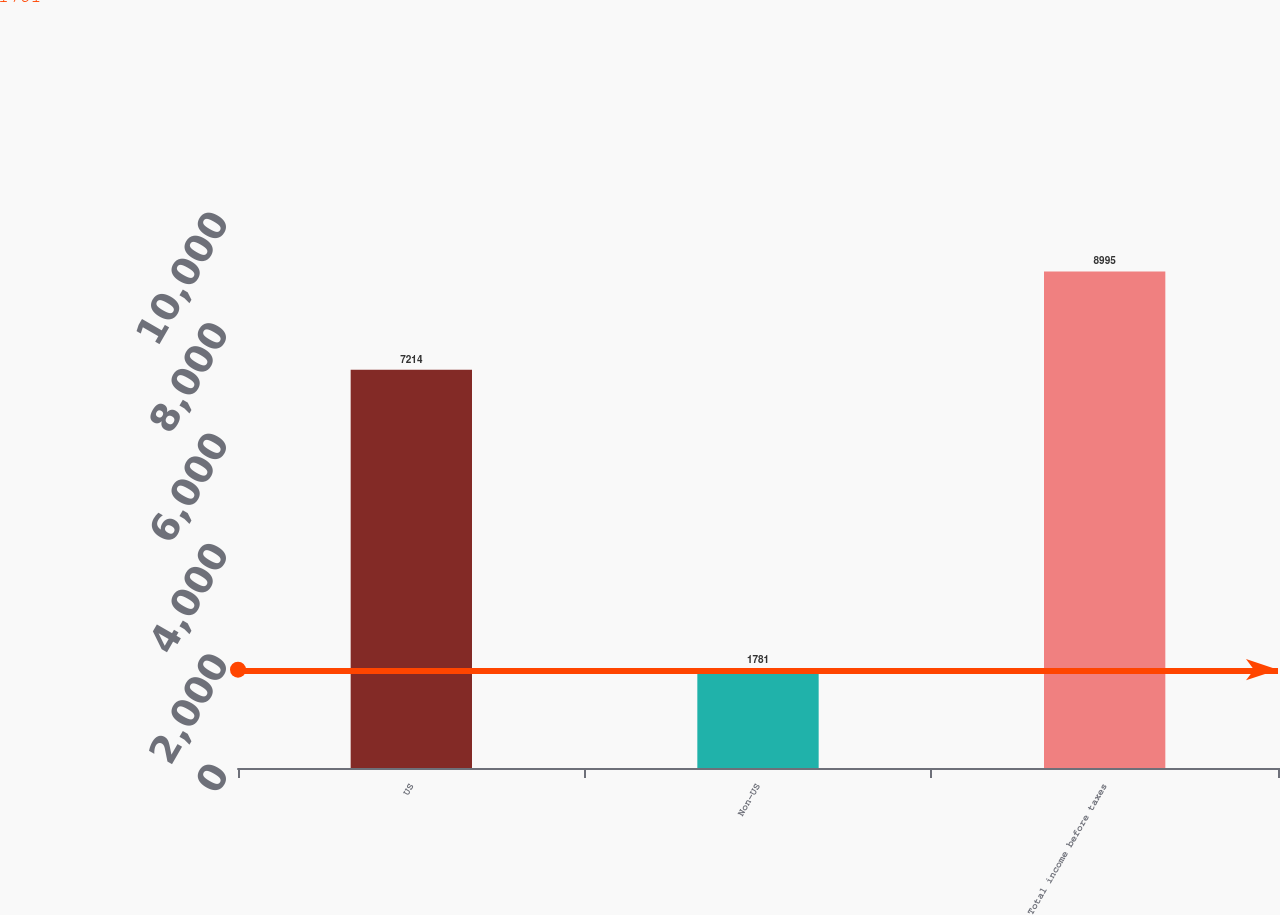Convert chart to OTSL. <chart><loc_0><loc_0><loc_500><loc_500><bar_chart><fcel>US<fcel>Non-US<fcel>Total income before taxes<nl><fcel>7214<fcel>1781<fcel>8995<nl></chart> 